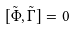Convert formula to latex. <formula><loc_0><loc_0><loc_500><loc_500>[ \tilde { \Phi } , \tilde { \Gamma } ] = 0</formula> 